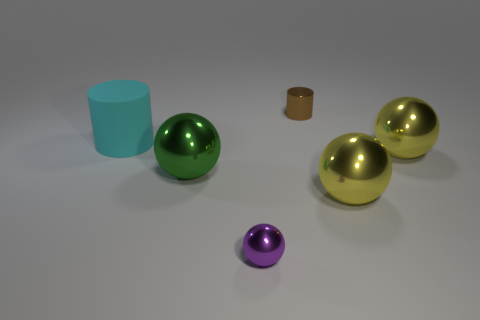How many objects in total are there, and can you describe their shapes? There are five objects in total. There are three spheres which are round 3D shapes, one cylinder which has circular ends and straight sides, and one tall cylinder with a height greater than its diameter. 